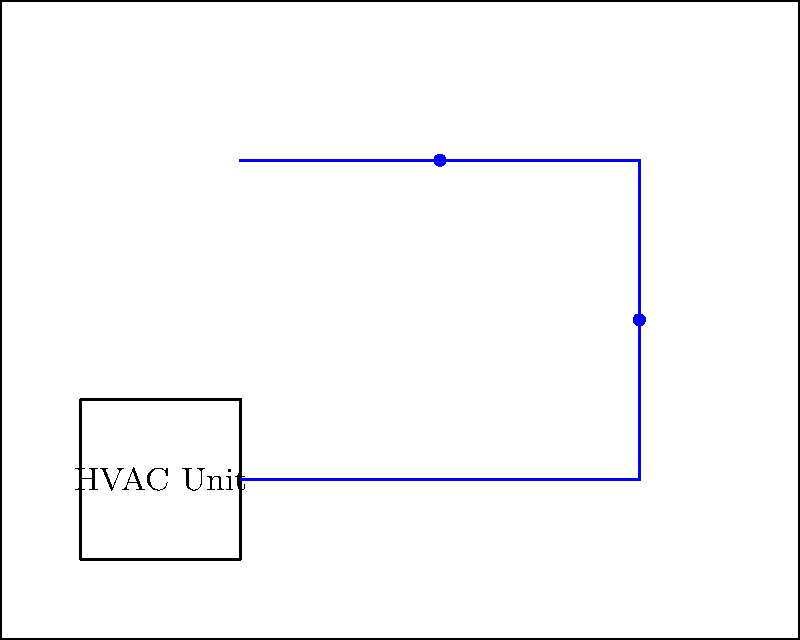In designing an optimal HVAC system layout for noise reduction in a home, which component shown in the diagram is most effective for minimizing vibration-induced noise transmission, and where should it be placed for maximum effectiveness? To determine the most effective component for minimizing vibration-induced noise transmission in an HVAC system, we need to consider the following steps:

1. Identify noise sources: The primary source of vibration-induced noise in an HVAC system is the HVAC unit itself, which contains moving parts like compressors and fans.

2. Understand noise transmission: Vibrations from the HVAC unit can propagate through the structure of the house, causing noise in other rooms.

3. Evaluate noise reduction methods:
   a) Insulation (green in the diagram): While effective for airborne noise, it's less effective for structure-borne vibrations.
   b) Vibration mounts (red in the diagram): These isolate the HVAC unit from the building structure, preventing vibration transmission.

4. Consider placement: Vibration mounts should be placed directly under the HVAC unit, between the unit and its supporting structure.

5. Assess effectiveness: Vibration mounts are most effective because they address the noise at its source, preventing vibrations from entering the building structure in the first place.

Therefore, the vibration mounts (shown in red) are the most effective component for minimizing vibration-induced noise transmission. They should be placed directly under the HVAC unit for maximum effectiveness.
Answer: Vibration mounts, placed under the HVAC unit 